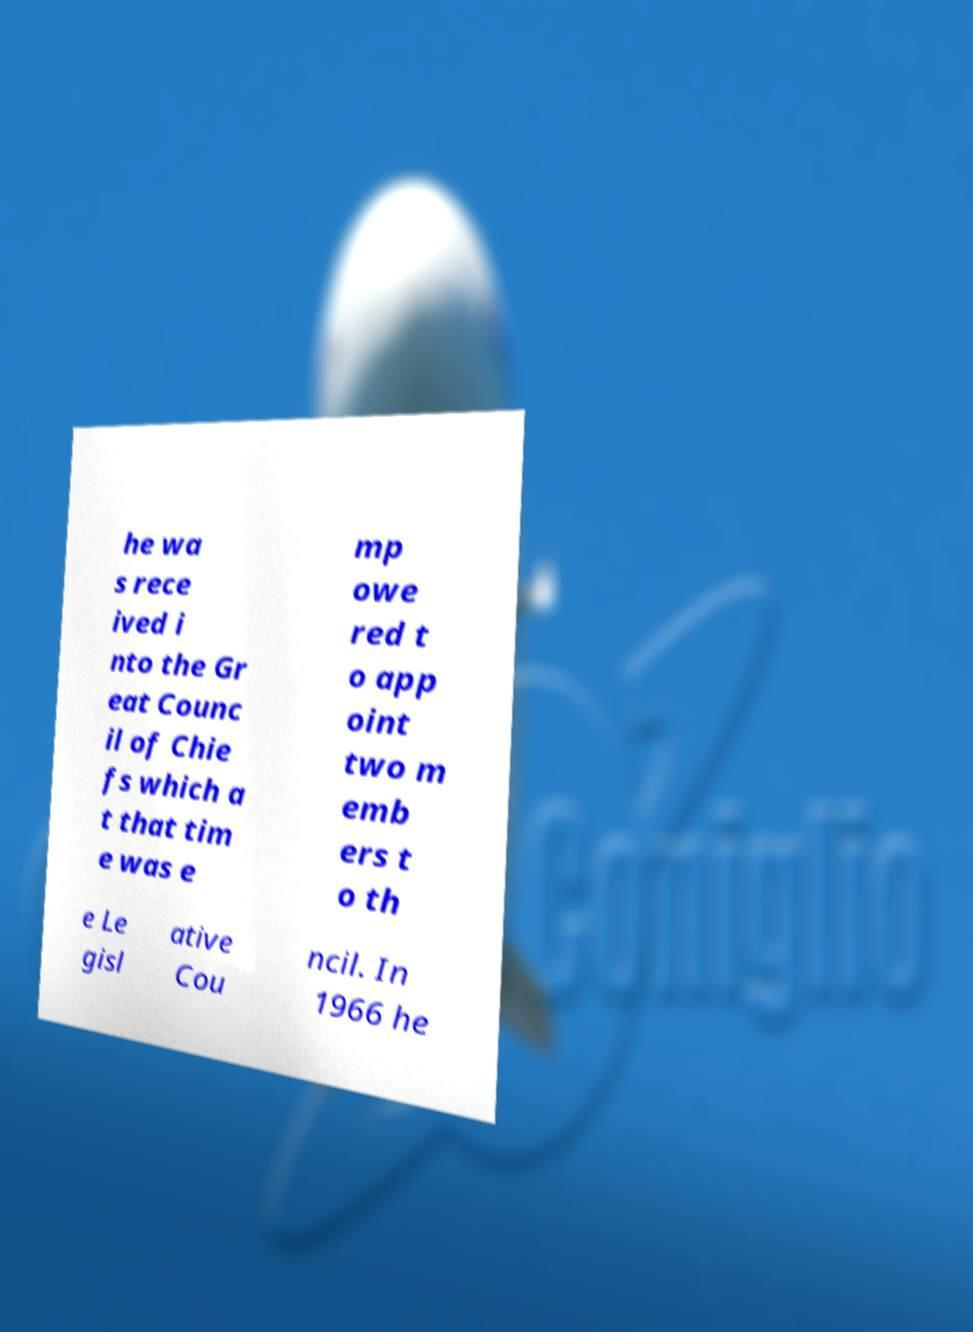Could you extract and type out the text from this image? he wa s rece ived i nto the Gr eat Counc il of Chie fs which a t that tim e was e mp owe red t o app oint two m emb ers t o th e Le gisl ative Cou ncil. In 1966 he 